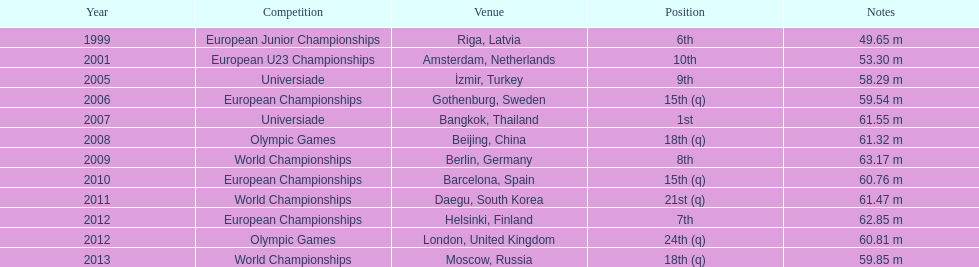How many global championships has he participated in? 3. 